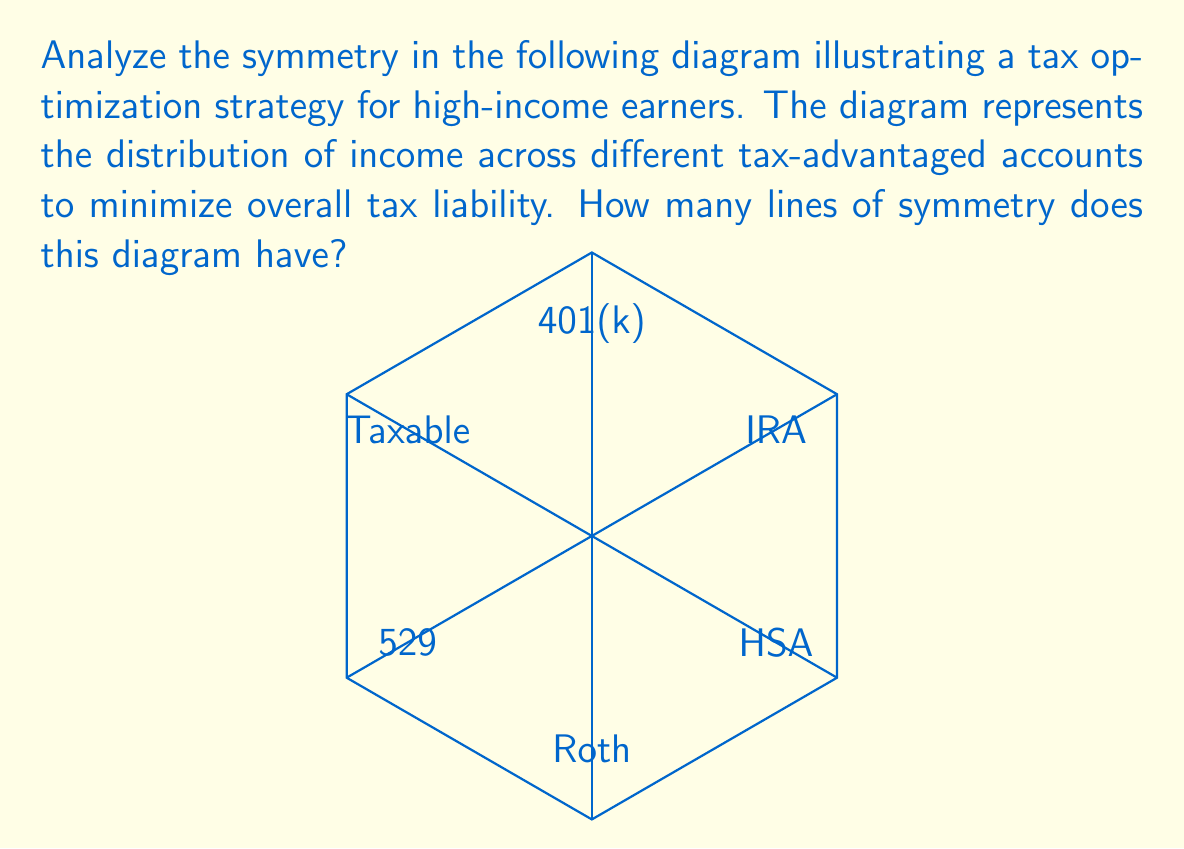What is the answer to this math problem? To determine the number of lines of symmetry in this diagram, we need to analyze its geometric properties:

1. The diagram is based on a regular hexagon, which inherently has 6 lines of symmetry:
   - 3 lines connecting opposite vertices
   - 3 lines connecting the midpoints of opposite sides

2. The internal structure of the hexagon (connecting opposite vertices) maintains this symmetry.

3. The labels representing different tax-advantaged accounts are placed symmetrically:
   - 401(k) and Roth are on opposite sides
   - IRA and 529 are on opposite sides
   - HSA and Taxable are on opposite sides

4. This labeling preserves all 6 lines of symmetry of the hexagon:
   - Vertical line: splits 401(k)/Roth
   - Two diagonal lines: split IRA/529 and HSA/Taxable
   - Horizontal line: splits between IRA/HSA and 529/Taxable
   - Two other diagonal lines: split between 401(k)/IRA and Roth/HSA, and between 401(k)/Taxable and Roth/529

Therefore, the diagram maintains all 6 lines of symmetry from the original hexagon structure.
Answer: 6 